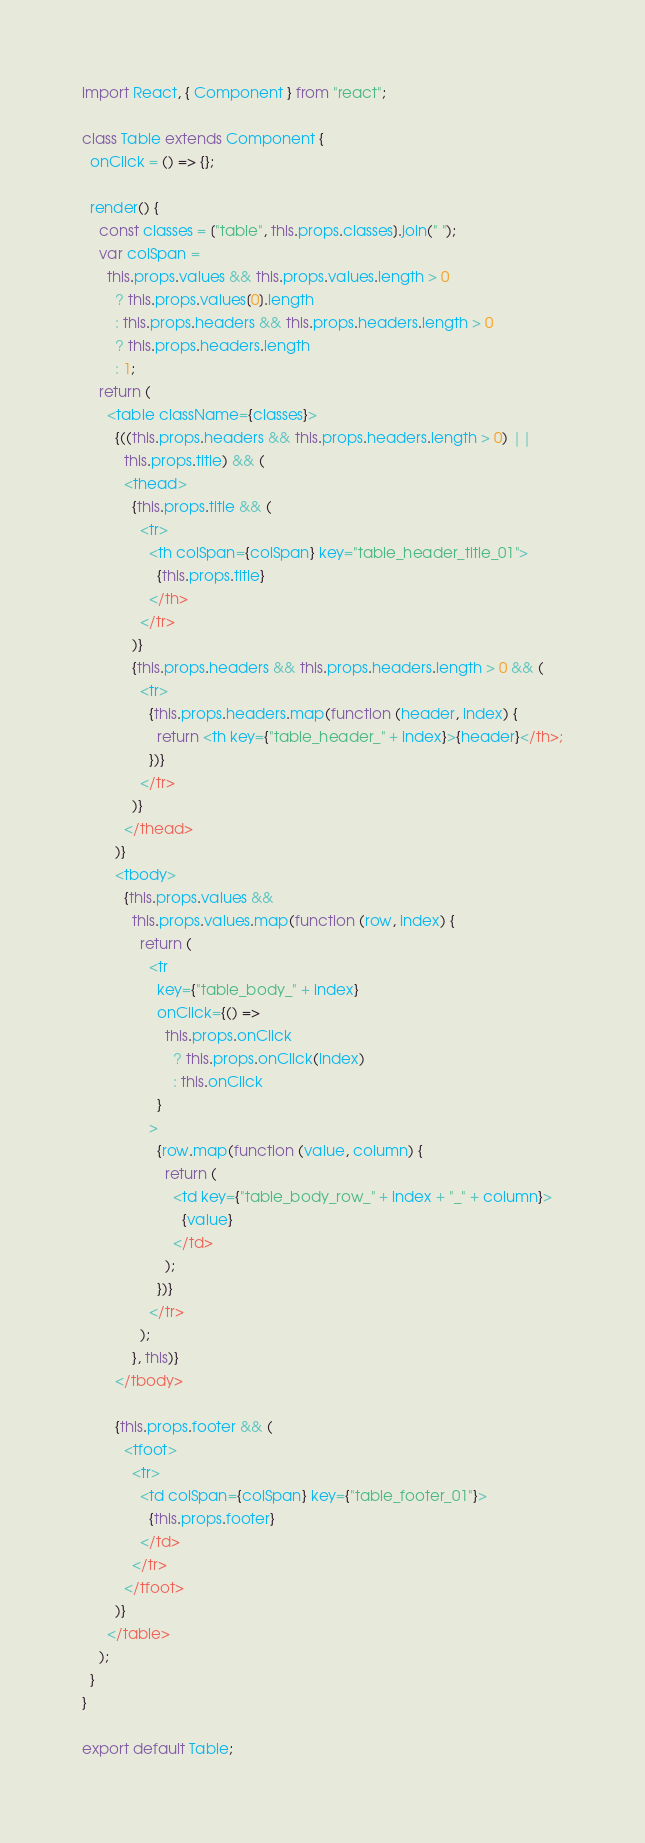<code> <loc_0><loc_0><loc_500><loc_500><_JavaScript_>import React, { Component } from "react";

class Table extends Component {
  onClick = () => {};

  render() {
    const classes = ["table", this.props.classes].join(" ");
    var colSpan =
      this.props.values && this.props.values.length > 0
        ? this.props.values[0].length
        : this.props.headers && this.props.headers.length > 0
        ? this.props.headers.length
        : 1;
    return (
      <table className={classes}>
        {((this.props.headers && this.props.headers.length > 0) ||
          this.props.title) && (
          <thead>
            {this.props.title && (
              <tr>
                <th colSpan={colSpan} key="table_header_title_01">
                  {this.props.title}
                </th>
              </tr>
            )}
            {this.props.headers && this.props.headers.length > 0 && (
              <tr>
                {this.props.headers.map(function (header, index) {
                  return <th key={"table_header_" + index}>{header}</th>;
                })}
              </tr>
            )}
          </thead>
        )}
        <tbody>
          {this.props.values &&
            this.props.values.map(function (row, index) {
              return (
                <tr
                  key={"table_body_" + index}
                  onClick={() =>
                    this.props.onClick
                      ? this.props.onClick(index)
                      : this.onClick
                  }
                >
                  {row.map(function (value, column) {
                    return (
                      <td key={"table_body_row_" + index + "_" + column}>
                        {value}
                      </td>
                    );
                  })}
                </tr>
              );
            }, this)}
        </tbody>

        {this.props.footer && (
          <tfoot>
            <tr>
              <td colSpan={colSpan} key={"table_footer_01"}>
                {this.props.footer}
              </td>
            </tr>
          </tfoot>
        )}
      </table>
    );
  }
}

export default Table;
</code> 